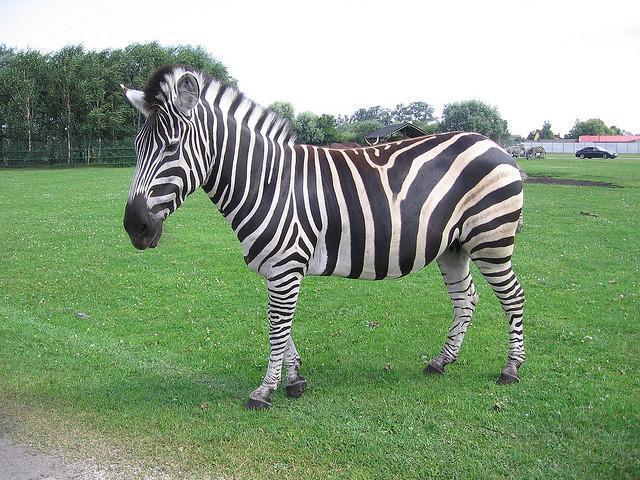How many people wear hat?
Give a very brief answer. 0. 